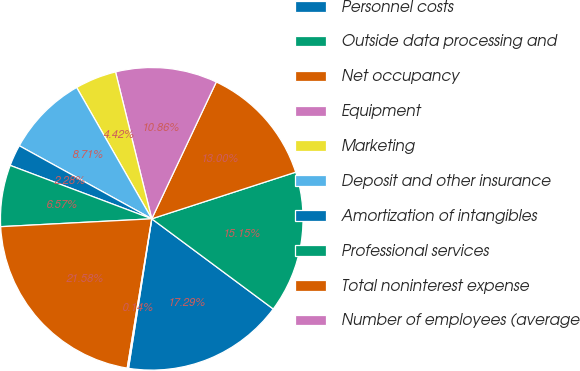<chart> <loc_0><loc_0><loc_500><loc_500><pie_chart><fcel>Personnel costs<fcel>Outside data processing and<fcel>Net occupancy<fcel>Equipment<fcel>Marketing<fcel>Deposit and other insurance<fcel>Amortization of intangibles<fcel>Professional services<fcel>Total noninterest expense<fcel>Number of employees (average<nl><fcel>17.29%<fcel>15.15%<fcel>13.0%<fcel>10.86%<fcel>4.42%<fcel>8.71%<fcel>2.28%<fcel>6.57%<fcel>21.58%<fcel>0.14%<nl></chart> 